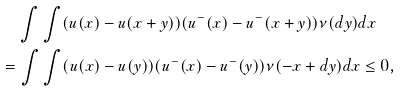<formula> <loc_0><loc_0><loc_500><loc_500>& \quad \int \int ( u ( x ) - u ( x + y ) ) ( u ^ { - } ( x ) - u ^ { - } ( x + y ) ) \nu ( d y ) d x \\ & = \int \int ( u ( x ) - u ( y ) ) ( u ^ { - } ( x ) - u ^ { - } ( y ) ) \nu ( - x + d y ) d x \leq 0 ,</formula> 